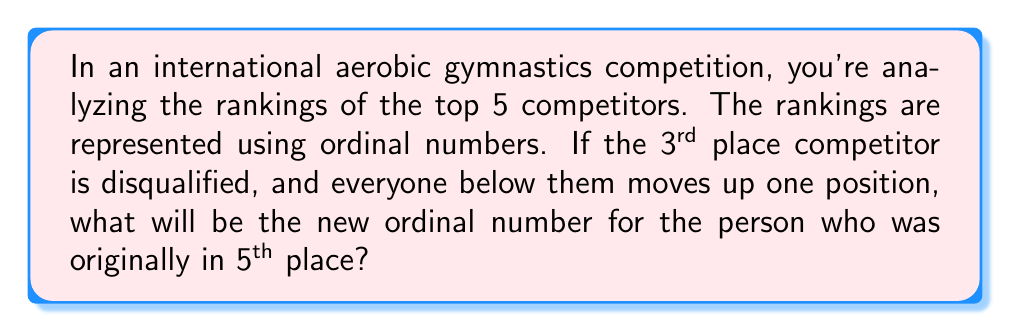Show me your answer to this math problem. Let's approach this step-by-step:

1) First, let's list the original rankings using ordinal numbers:
   1st, 2nd, 3rd, 4th, 5th

2) When the 3rd place competitor is disqualified, everyone below them moves up one position. This means:
   - 4th place moves to 3rd
   - 5th place moves to 4th

3) The new rankings would be:
   1st, 2nd, (disqualified), 3rd (formerly 4th), 4th (formerly 5th)

4) We're asked about the new position of the person who was originally in 5th place.

5) As we can see from step 3, the person who was originally in 5th place is now in 4th place.

6) In ordinal number system, 4th is represented as 4th.

Therefore, the new ordinal number for the person who was originally in 5th place is 4th.
Answer: 4th 